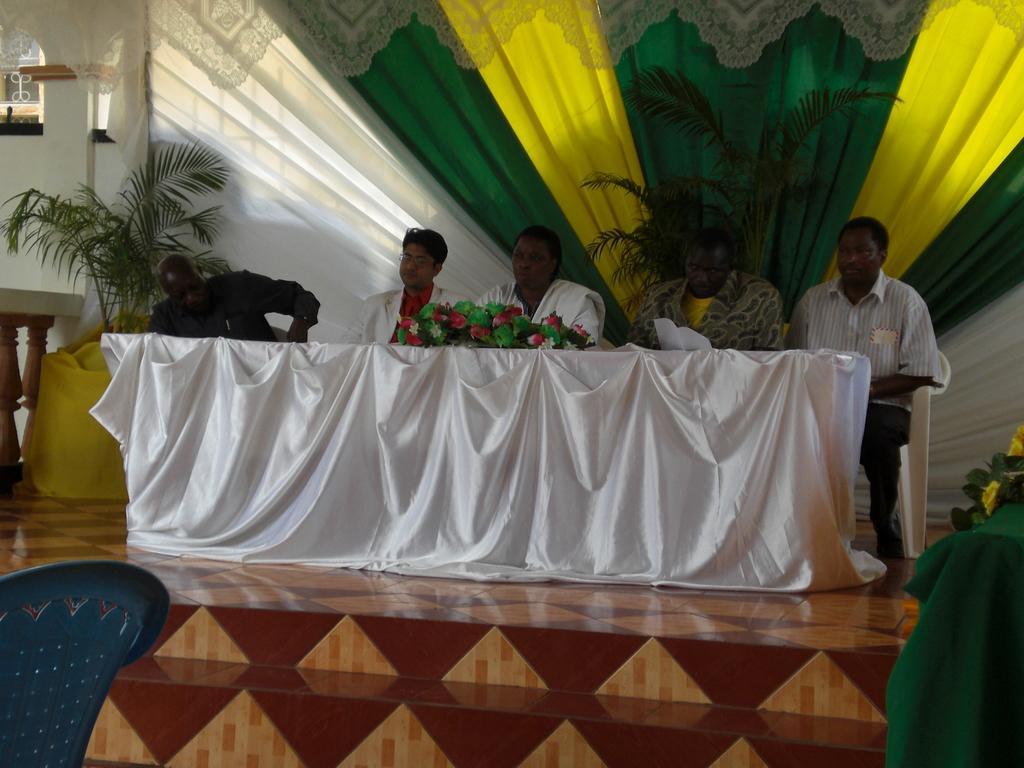Can you describe this image briefly? In the picture I can see some persons sitting on chair behind table which is covered with white cloth and there are some flowers on table and in the background of the picture there are some plants, multi color cloth and there is a wall. 